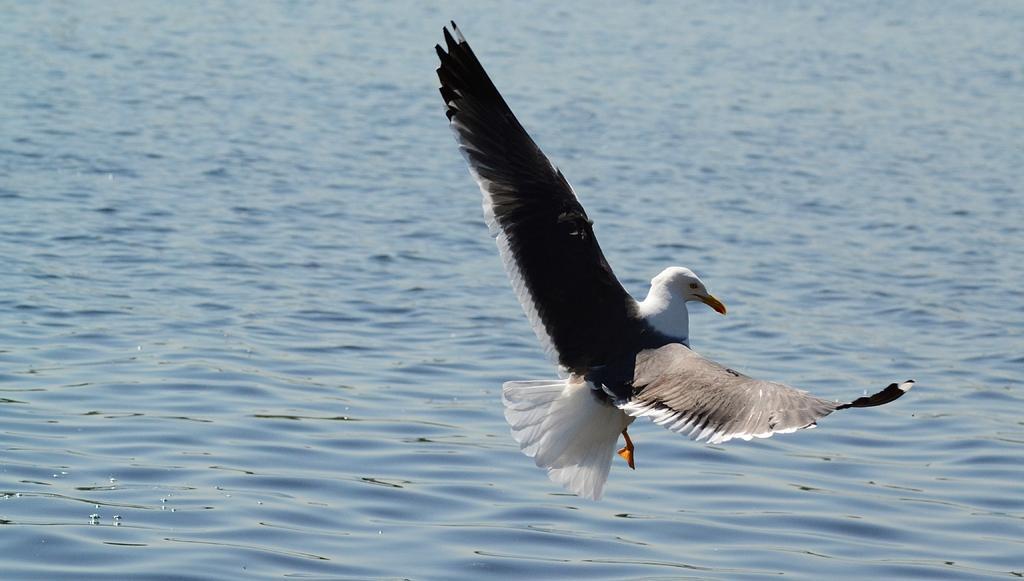In one or two sentences, can you explain what this image depicts? In the foreground of this image, there is a bird in the air above the water surface. 